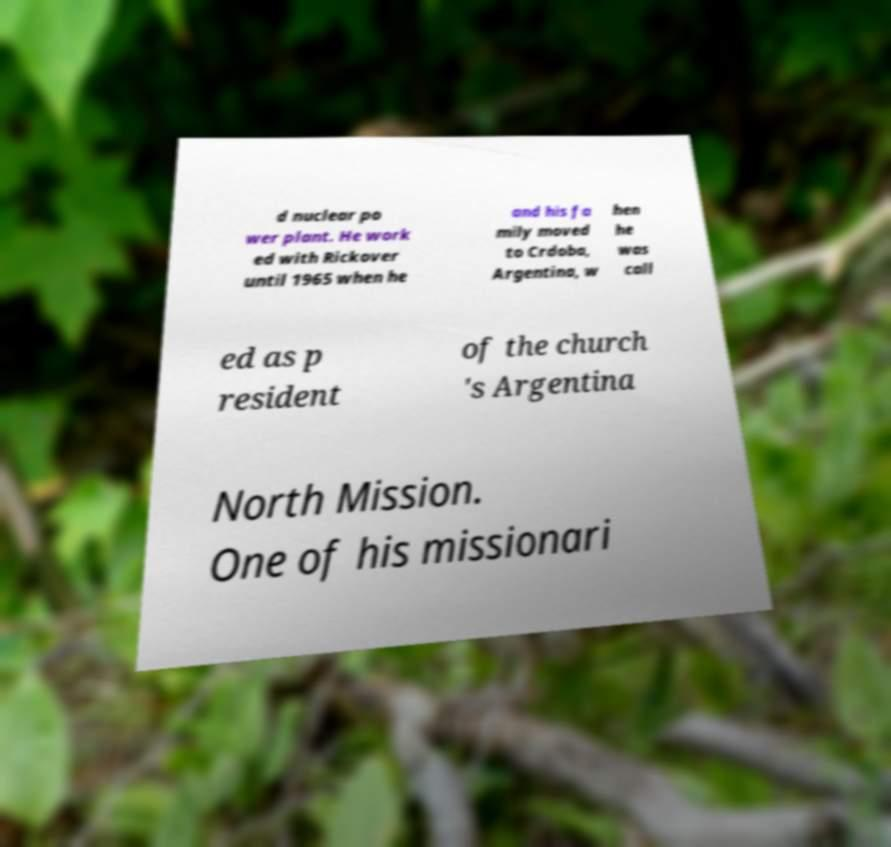Could you extract and type out the text from this image? d nuclear po wer plant. He work ed with Rickover until 1965 when he and his fa mily moved to Crdoba, Argentina, w hen he was call ed as p resident of the church 's Argentina North Mission. One of his missionari 